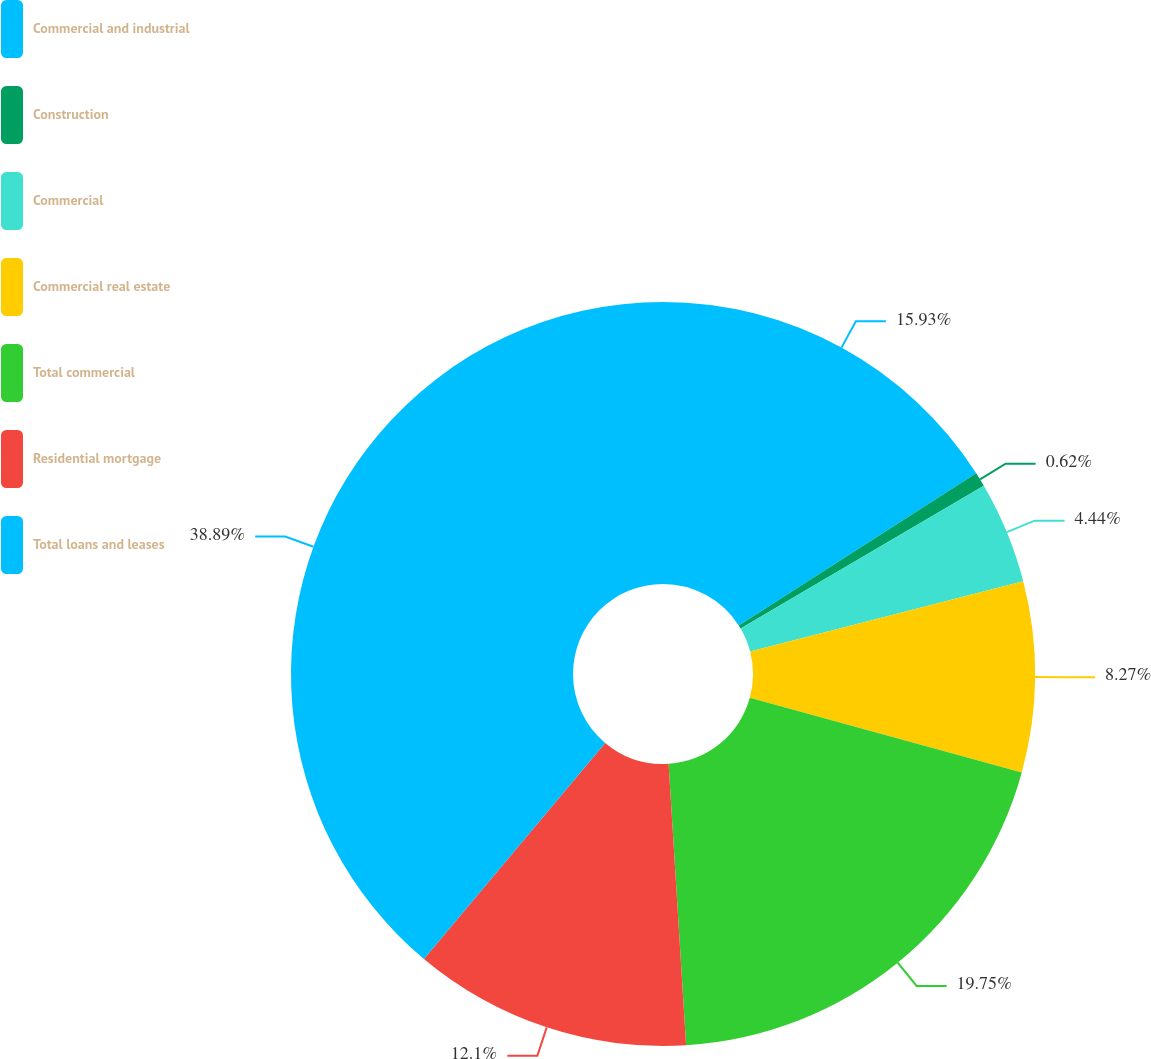Convert chart. <chart><loc_0><loc_0><loc_500><loc_500><pie_chart><fcel>Commercial and industrial<fcel>Construction<fcel>Commercial<fcel>Commercial real estate<fcel>Total commercial<fcel>Residential mortgage<fcel>Total loans and leases<nl><fcel>15.93%<fcel>0.62%<fcel>4.44%<fcel>8.27%<fcel>19.75%<fcel>12.1%<fcel>38.89%<nl></chart> 